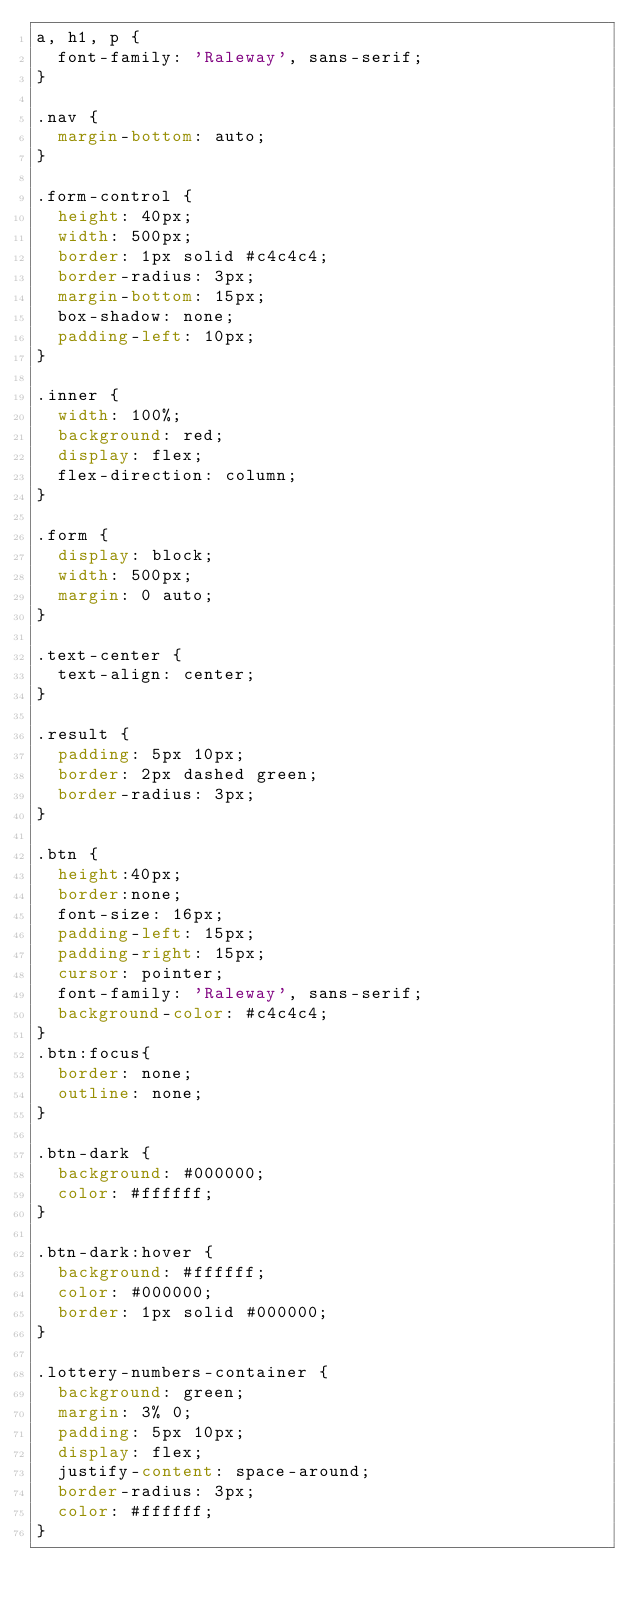Convert code to text. <code><loc_0><loc_0><loc_500><loc_500><_CSS_>a, h1, p {
	font-family: 'Raleway', sans-serif;
}

.nav {
	margin-bottom: auto;
}

.form-control {
	height: 40px;
	width: 500px;
	border: 1px solid #c4c4c4;
	border-radius: 3px;
	margin-bottom: 15px;
	box-shadow: none;
	padding-left: 10px;
}

.inner {
	width: 100%;
	background: red;
	display: flex;
	flex-direction: column;
}

.form {
	display: block;
	width: 500px;
	margin: 0 auto;
}

.text-center {
	text-align: center;
}

.result {
	padding: 5px 10px;
	border: 2px dashed green;
	border-radius: 3px;
}

.btn {
	height:40px;
	border:none;
	font-size: 16px;
	padding-left: 15px;
	padding-right: 15px;
	cursor: pointer;
	font-family: 'Raleway', sans-serif;
	background-color: #c4c4c4;
}
.btn:focus{
  border: none;
  outline: none;
}

.btn-dark {
	background: #000000;
	color: #ffffff;
}

.btn-dark:hover {
	background: #ffffff;
	color: #000000;
	border: 1px solid #000000;	
}

.lottery-numbers-container {
	background: green;
	margin: 3% 0;
	padding: 5px 10px;
	display: flex;
	justify-content: space-around;
	border-radius: 3px;
	color: #ffffff;
}</code> 